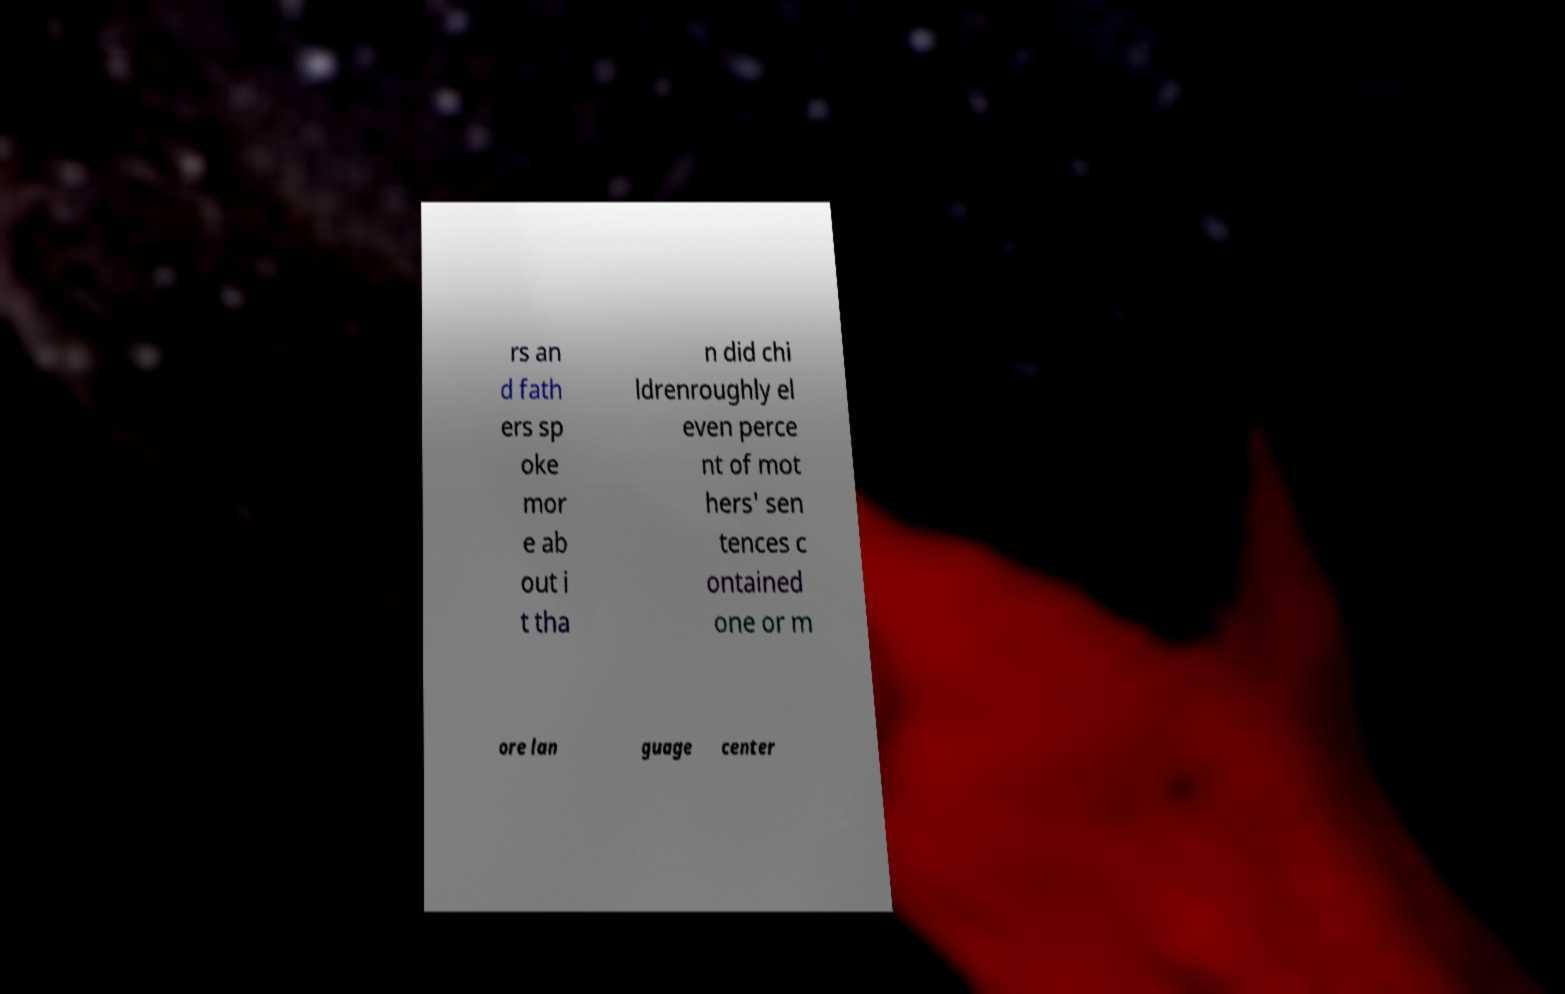Could you assist in decoding the text presented in this image and type it out clearly? rs an d fath ers sp oke mor e ab out i t tha n did chi ldrenroughly el even perce nt of mot hers' sen tences c ontained one or m ore lan guage center 